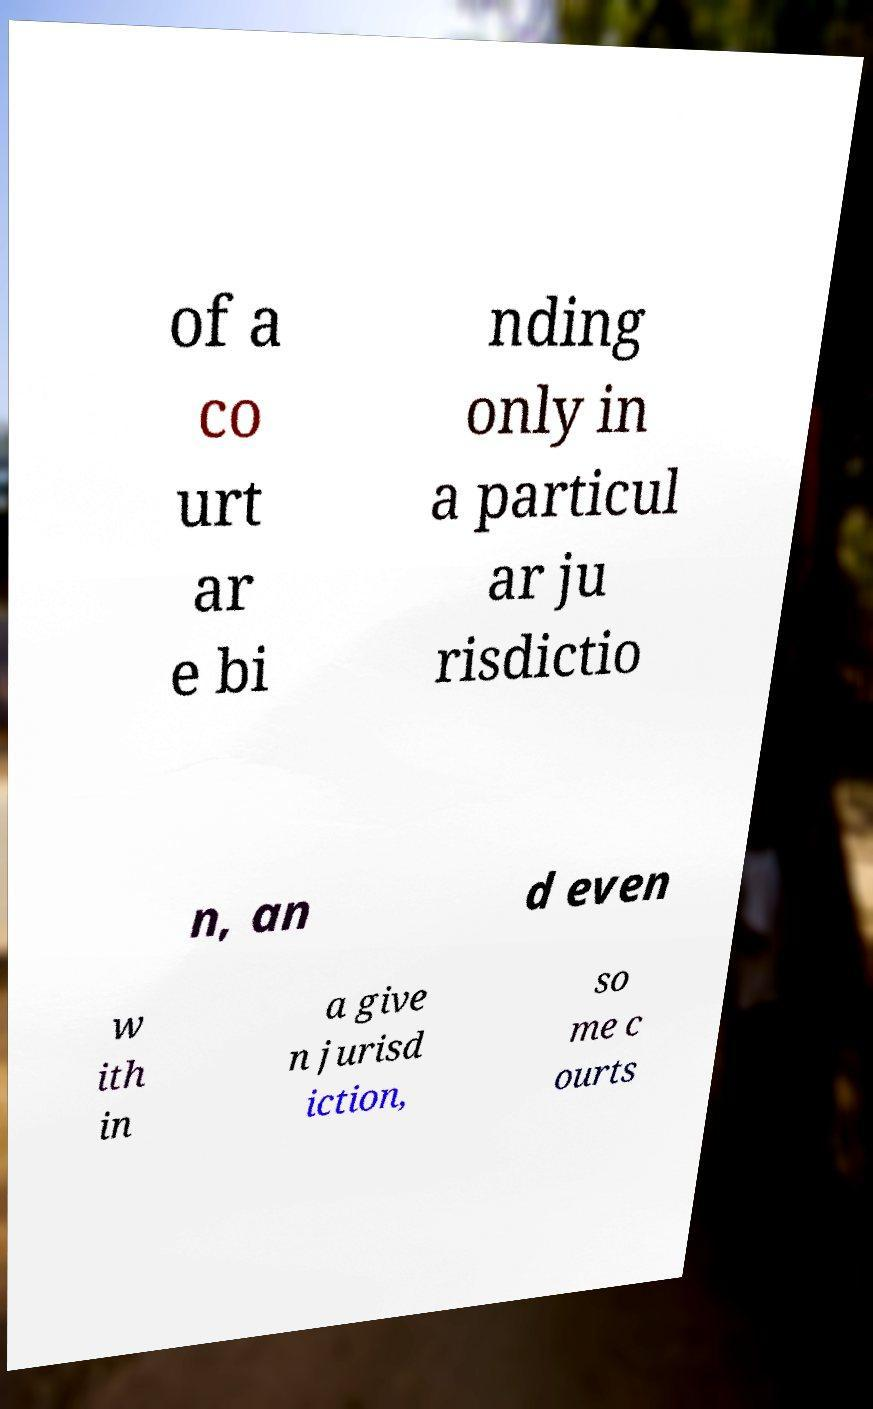Can you accurately transcribe the text from the provided image for me? of a co urt ar e bi nding only in a particul ar ju risdictio n, an d even w ith in a give n jurisd iction, so me c ourts 